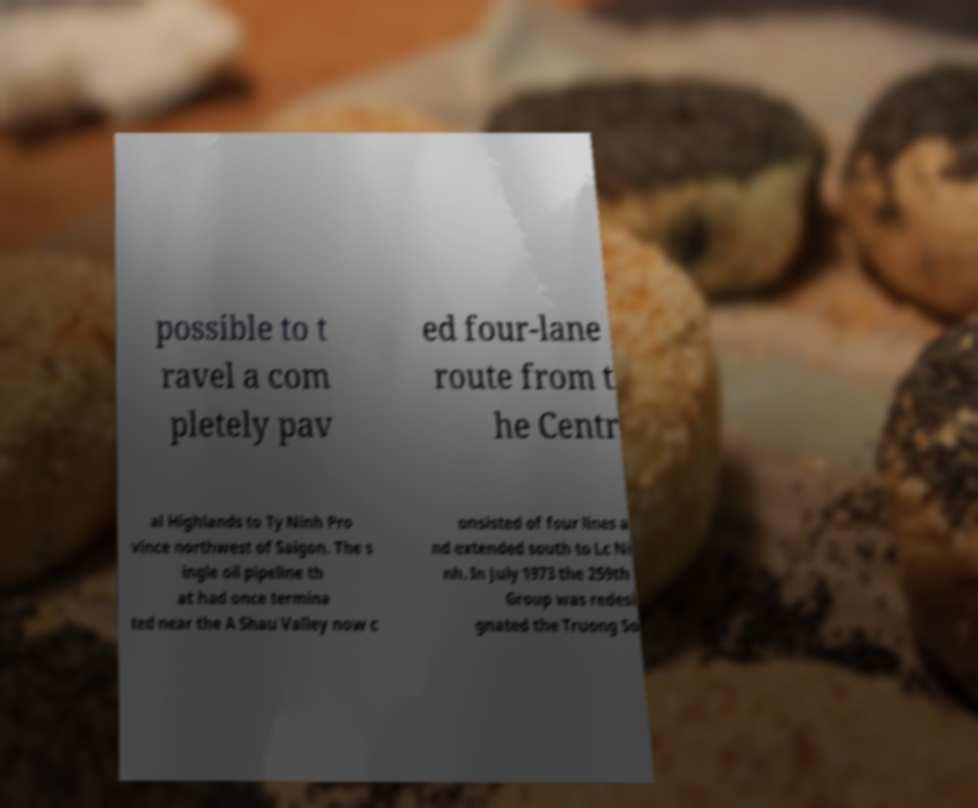Could you extract and type out the text from this image? possible to t ravel a com pletely pav ed four-lane route from t he Centr al Highlands to Ty Ninh Pro vince northwest of Saigon. The s ingle oil pipeline th at had once termina ted near the A Shau Valley now c onsisted of four lines a nd extended south to Lc Ni nh. In July 1973 the 259th Group was redesi gnated the Truong So 